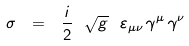<formula> <loc_0><loc_0><loc_500><loc_500>\sigma \ = \ \frac { i } { 2 } \ \sqrt { g } \ \varepsilon _ { \mu \nu } \, \gamma ^ { \mu } \, \gamma ^ { \nu }</formula> 